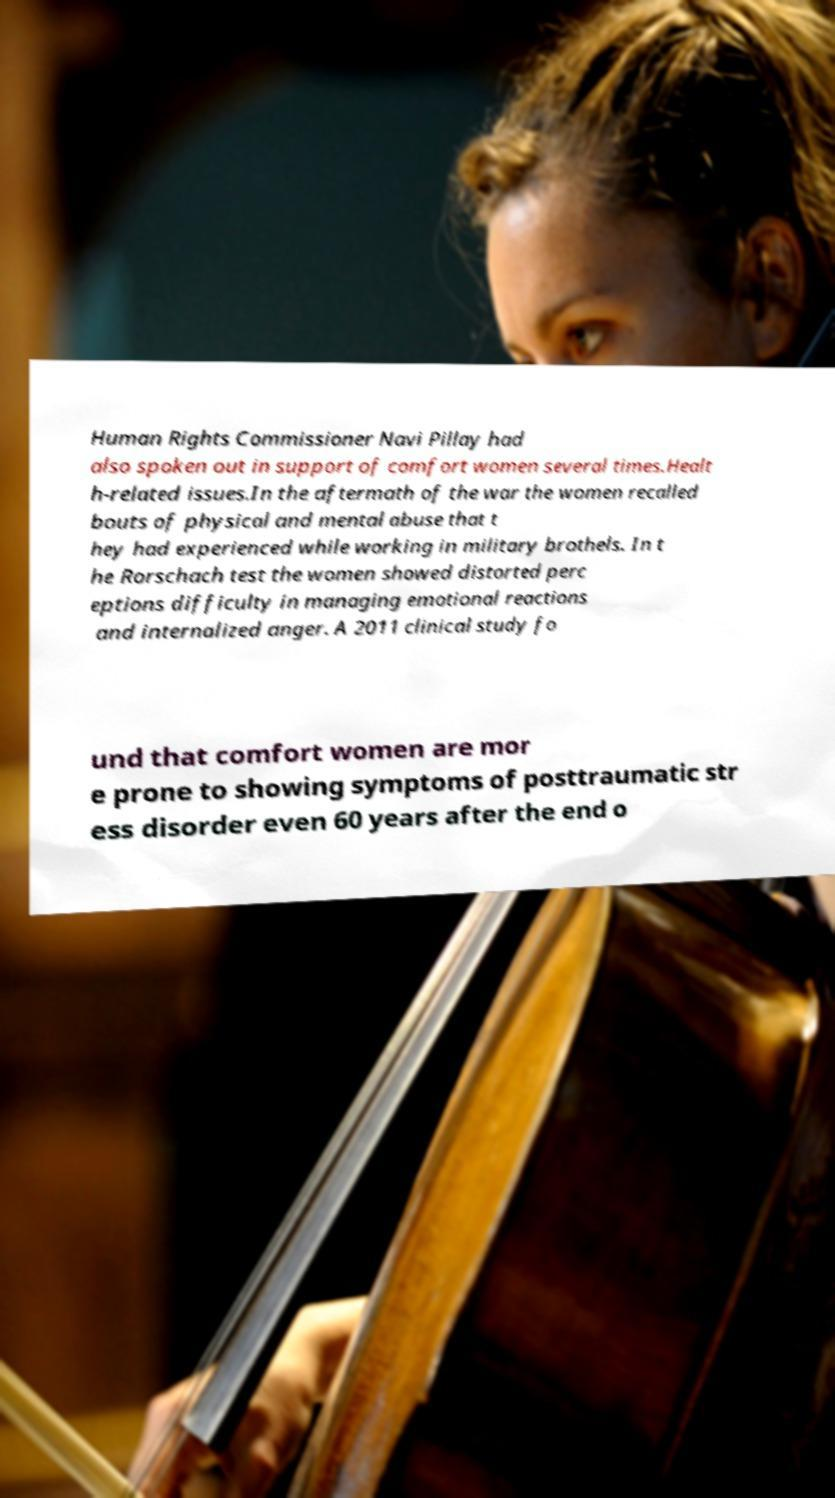For documentation purposes, I need the text within this image transcribed. Could you provide that? Human Rights Commissioner Navi Pillay had also spoken out in support of comfort women several times.Healt h-related issues.In the aftermath of the war the women recalled bouts of physical and mental abuse that t hey had experienced while working in military brothels. In t he Rorschach test the women showed distorted perc eptions difficulty in managing emotional reactions and internalized anger. A 2011 clinical study fo und that comfort women are mor e prone to showing symptoms of posttraumatic str ess disorder even 60 years after the end o 